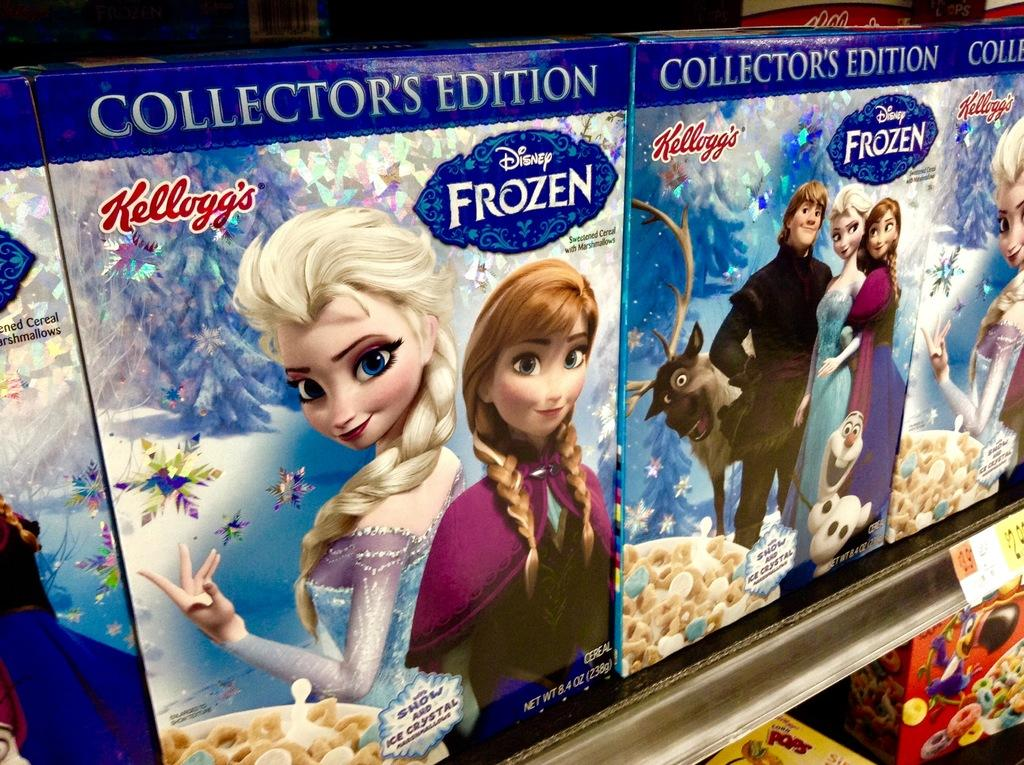What can be found in the shelves in the image? There are snacks boxes in the shelves. Is there any information about the price of the items in the image? Yes, there is a price tag in front of the shelf. How many rooms can be seen in the image? There is no information about rooms in the image; it only shows snacks boxes in the shelves and a price tag. What type of wash is used to clean the snacks boxes in the image? There is no information about washing the snacks boxes in the image; it only shows them in the shelves and a price tag. 